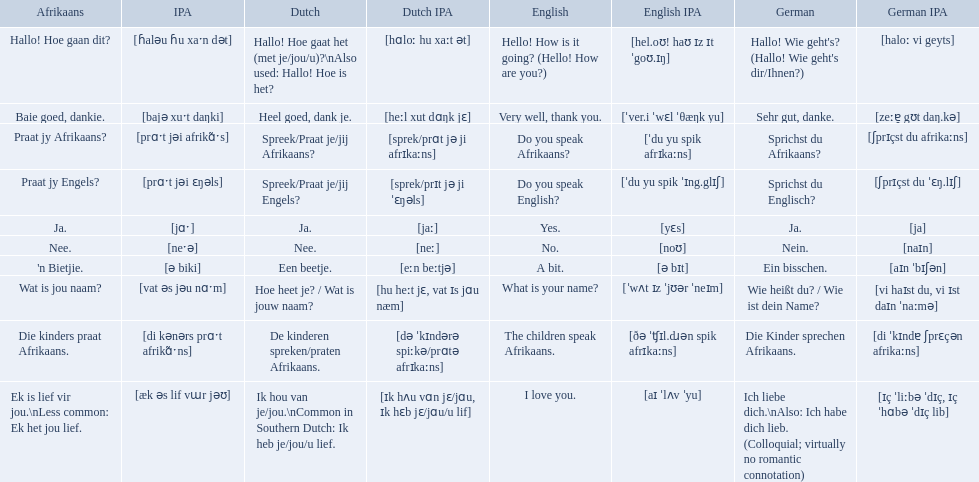What are the afrikaans phrases? Hallo! Hoe gaan dit?, Baie goed, dankie., Praat jy Afrikaans?, Praat jy Engels?, Ja., Nee., 'n Bietjie., Wat is jou naam?, Die kinders praat Afrikaans., Ek is lief vir jou.\nLess common: Ek het jou lief. For die kinders praat afrikaans, what are the translations? De kinderen spreken/praten Afrikaans., The children speak Afrikaans., Die Kinder sprechen Afrikaans. Which one is the german translation? Die Kinder sprechen Afrikaans. How do you say hello! how is it going? in afrikaans? Hallo! Hoe gaan dit?. How do you say very well, thank you in afrikaans? Baie goed, dankie. How would you say do you speak afrikaans? in afrikaans? Praat jy Afrikaans?. Which phrases are said in africaans? Hallo! Hoe gaan dit?, Baie goed, dankie., Praat jy Afrikaans?, Praat jy Engels?, Ja., Nee., 'n Bietjie., Wat is jou naam?, Die kinders praat Afrikaans., Ek is lief vir jou.\nLess common: Ek het jou lief. Which of these mean how do you speak afrikaans? Praat jy Afrikaans?. 